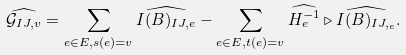<formula> <loc_0><loc_0><loc_500><loc_500>\widehat { \mathcal { G } _ { I J , v } } = \sum _ { e \in E , s ( e ) = v } \widehat { I ( B ) _ { I J , e } } - \sum _ { e \in E , t ( e ) = v } \widehat { H _ { e } ^ { - 1 } } \triangleright \widehat { I ( B ) _ { I J , _ { e } } } .</formula> 